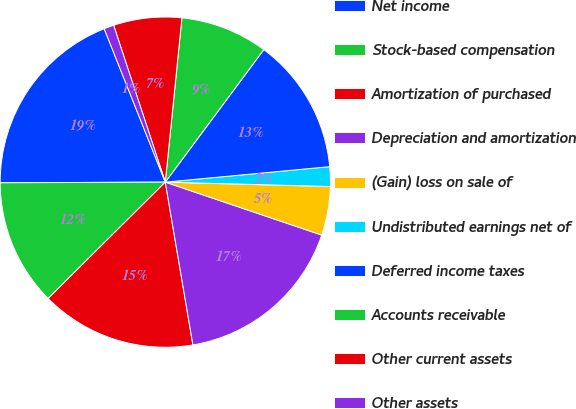Convert chart. <chart><loc_0><loc_0><loc_500><loc_500><pie_chart><fcel>Net income<fcel>Stock-based compensation<fcel>Amortization of purchased<fcel>Depreciation and amortization<fcel>(Gain) loss on sale of<fcel>Undistributed earnings net of<fcel>Deferred income taxes<fcel>Accounts receivable<fcel>Other current assets<fcel>Other assets<nl><fcel>19.03%<fcel>12.38%<fcel>15.23%<fcel>17.13%<fcel>4.77%<fcel>1.92%<fcel>13.33%<fcel>8.57%<fcel>6.67%<fcel>0.97%<nl></chart> 